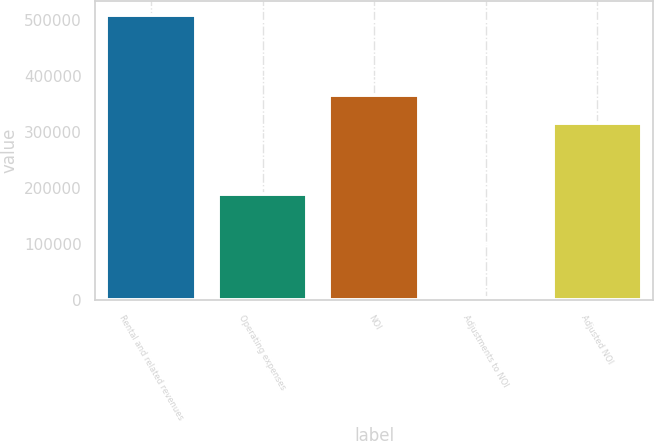<chart> <loc_0><loc_0><loc_500><loc_500><bar_chart><fcel>Rental and related revenues<fcel>Operating expenses<fcel>NOI<fcel>Adjustments to NOI<fcel>Adjusted NOI<nl><fcel>509019<fcel>189859<fcel>366873<fcel>2899<fcel>316261<nl></chart> 